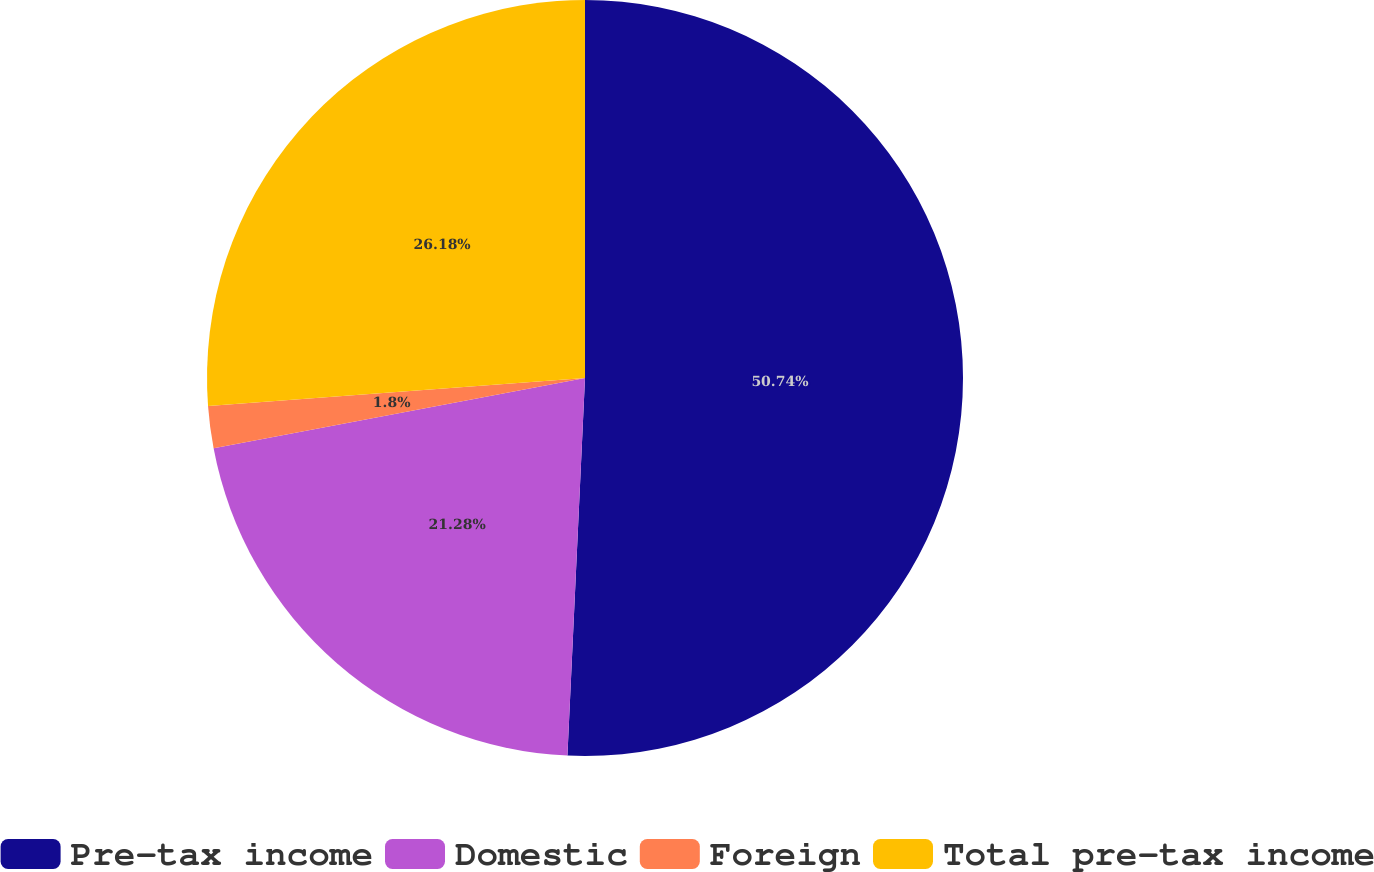Convert chart. <chart><loc_0><loc_0><loc_500><loc_500><pie_chart><fcel>Pre-tax income<fcel>Domestic<fcel>Foreign<fcel>Total pre-tax income<nl><fcel>50.74%<fcel>21.28%<fcel>1.8%<fcel>26.18%<nl></chart> 